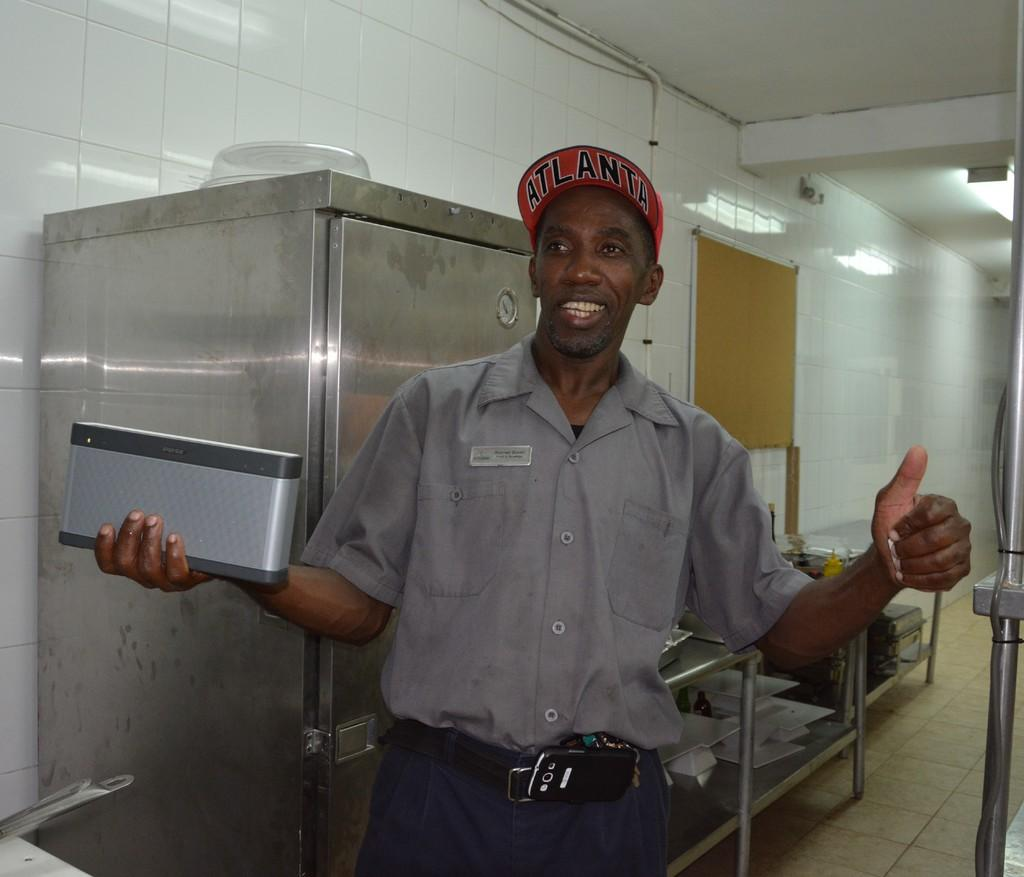<image>
Offer a succinct explanation of the picture presented. a man with a hat on that says Atlanta 